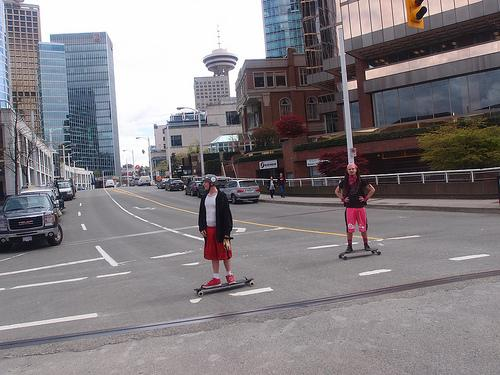What are the colors of the shorts being worn by the man with the pink bandana? The man with the pink bandana is wearing pink and black shorts. What are the two people doing together in the image? The two people are skateboarding in the street. What is the color of the car parked on the side of the road? The car parked on the side of the road is grey. Who in the image is wearing a helmet, and what is its color? The man on the skateboard is wearing a black and white helmet. Describe the colors of the traffic light in the image. The traffic light has a yellow light on. How can we describe the windows on the building in the image? The windows on the building are arranged in a grid pattern and are uniformly sized. What are the two skateboarders doing in the image? The two skateboarders are crossing the street. What type of board is the skateboarder in baggy clothes using? The skateboard is a longboard. What is the guy with the pink scarf wearing as bottoms? The guy with the pink scarf is wearing pink and black shorts. Identify the unique feature of the building mentioned in the image. The tall building has a satellite needle on top. 